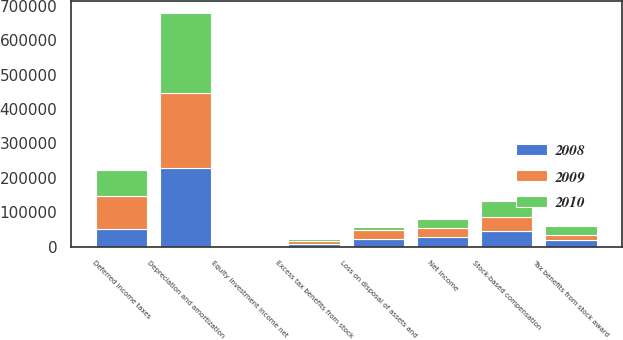Convert chart to OTSL. <chart><loc_0><loc_0><loc_500><loc_500><stacked_bar_chart><ecel><fcel>Net income<fcel>Depreciation and amortization<fcel>Stock-based compensation<fcel>Tax benefits from stock award<fcel>Excess tax benefits from stock<fcel>Deferred income taxes<fcel>Equity investment income net<fcel>Loss on disposal of assets and<nl><fcel>2010<fcel>26706<fcel>234378<fcel>45551<fcel>26706<fcel>6283<fcel>75399<fcel>3298<fcel>9585<nl><fcel>2008<fcel>26706<fcel>228986<fcel>44422<fcel>18241<fcel>6950<fcel>50869<fcel>204<fcel>20945<nl><fcel>2009<fcel>26706<fcel>216917<fcel>41235<fcel>13988<fcel>8013<fcel>94912<fcel>796<fcel>27010<nl></chart> 